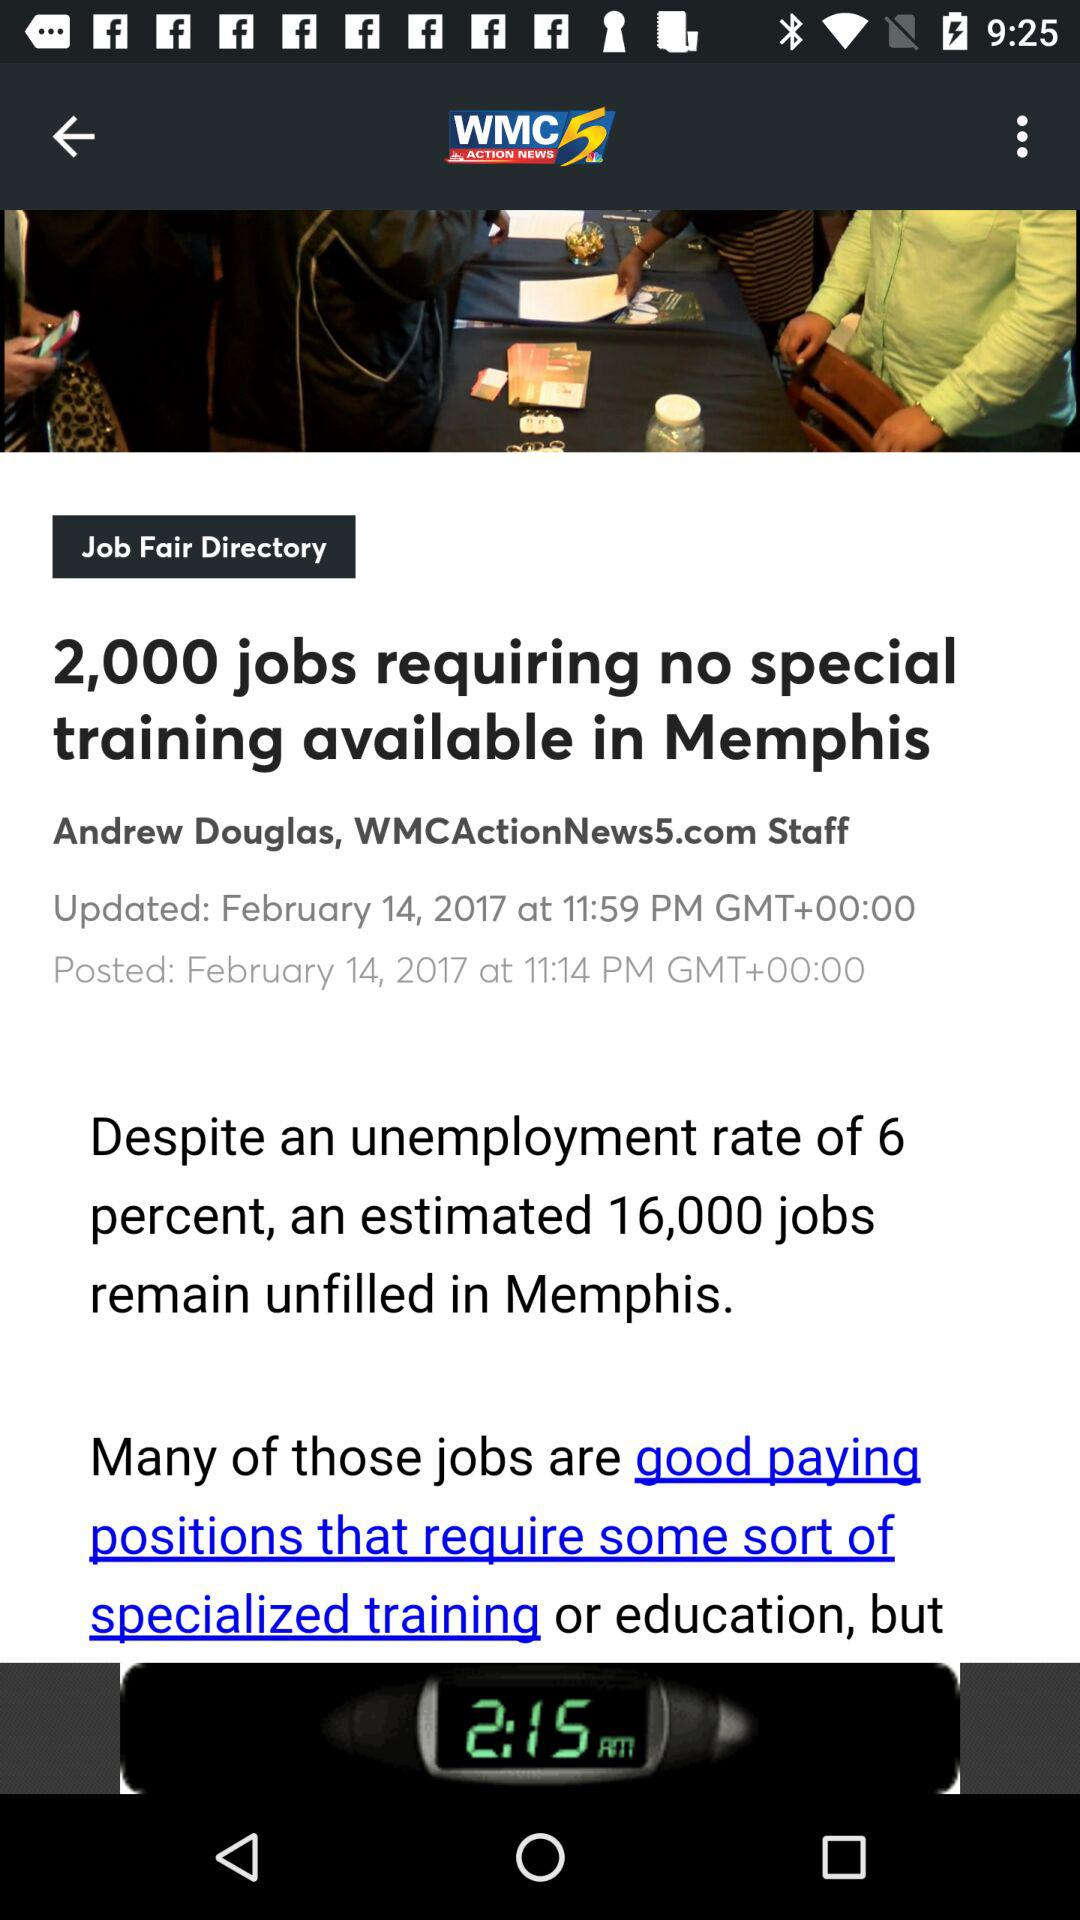How many jobs remain unfilled in Memphis? In Memphis, an estimated 16,000 jobs remain unfilled. 